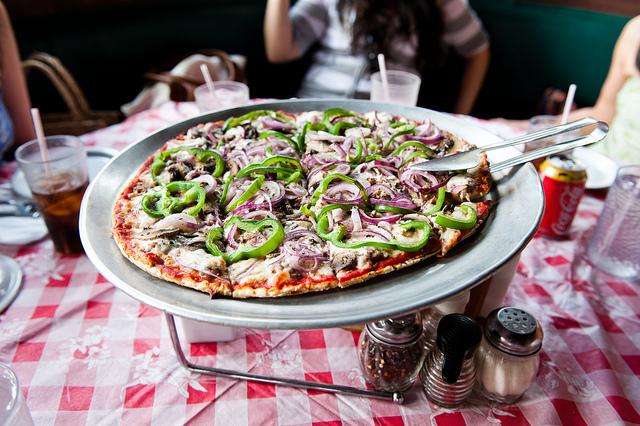How many straws in the picture?
Keep it brief. 4. Are the drinks cold or hot?
Quick response, please. Cold. What type of meal is this?
Short answer required. Pizza. 